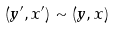<formula> <loc_0><loc_0><loc_500><loc_500>( y ^ { \prime } , x ^ { \prime } ) \sim ( y , x )</formula> 